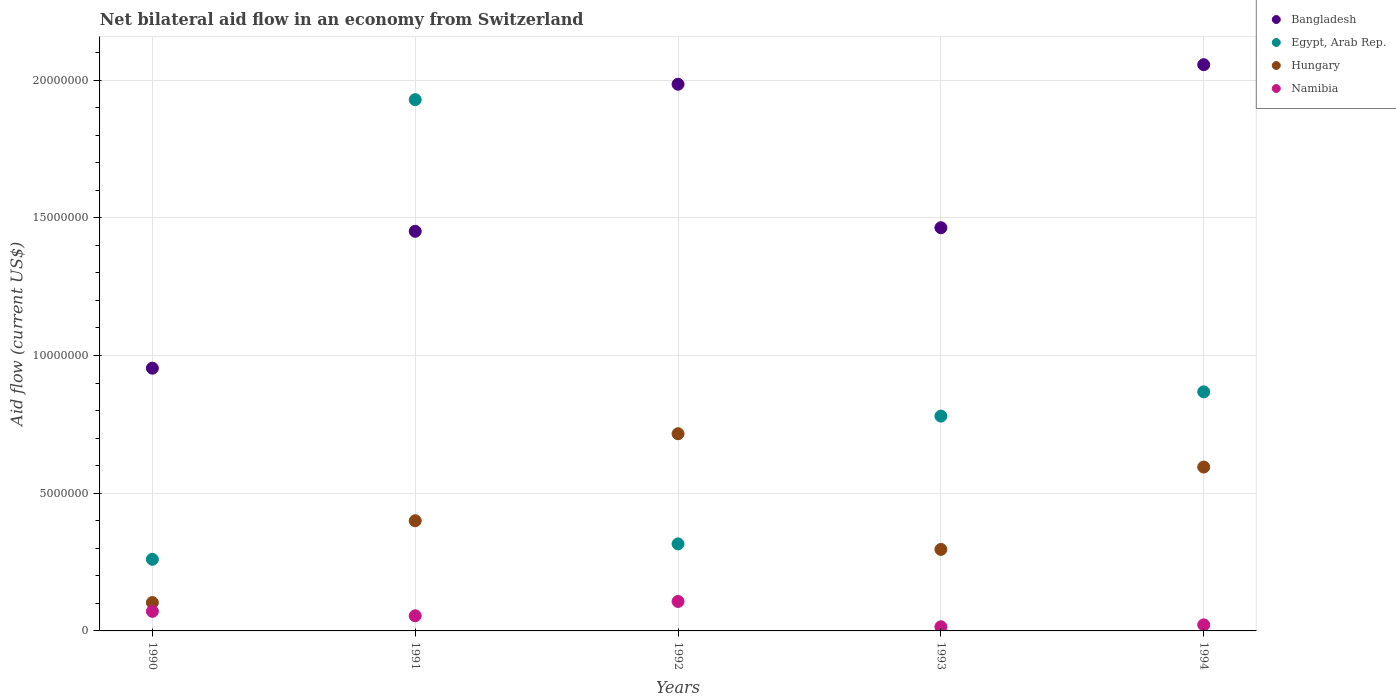How many different coloured dotlines are there?
Your answer should be compact. 4. Is the number of dotlines equal to the number of legend labels?
Provide a short and direct response. Yes. What is the net bilateral aid flow in Egypt, Arab Rep. in 1994?
Keep it short and to the point. 8.68e+06. Across all years, what is the maximum net bilateral aid flow in Bangladesh?
Provide a short and direct response. 2.06e+07. Across all years, what is the minimum net bilateral aid flow in Bangladesh?
Give a very brief answer. 9.54e+06. What is the total net bilateral aid flow in Hungary in the graph?
Give a very brief answer. 2.11e+07. What is the difference between the net bilateral aid flow in Hungary in 1990 and that in 1991?
Provide a short and direct response. -2.97e+06. What is the difference between the net bilateral aid flow in Namibia in 1994 and the net bilateral aid flow in Egypt, Arab Rep. in 1990?
Your answer should be compact. -2.38e+06. What is the average net bilateral aid flow in Bangladesh per year?
Give a very brief answer. 1.58e+07. In the year 1991, what is the difference between the net bilateral aid flow in Namibia and net bilateral aid flow in Bangladesh?
Offer a very short reply. -1.40e+07. What is the ratio of the net bilateral aid flow in Egypt, Arab Rep. in 1990 to that in 1991?
Make the answer very short. 0.13. Is the net bilateral aid flow in Hungary in 1992 less than that in 1994?
Offer a very short reply. No. Is the difference between the net bilateral aid flow in Namibia in 1992 and 1993 greater than the difference between the net bilateral aid flow in Bangladesh in 1992 and 1993?
Your response must be concise. No. What is the difference between the highest and the second highest net bilateral aid flow in Hungary?
Your response must be concise. 1.21e+06. What is the difference between the highest and the lowest net bilateral aid flow in Namibia?
Offer a terse response. 9.20e+05. Is the sum of the net bilateral aid flow in Egypt, Arab Rep. in 1991 and 1994 greater than the maximum net bilateral aid flow in Hungary across all years?
Your answer should be compact. Yes. Is the net bilateral aid flow in Bangladesh strictly greater than the net bilateral aid flow in Namibia over the years?
Make the answer very short. Yes. Is the net bilateral aid flow in Bangladesh strictly less than the net bilateral aid flow in Hungary over the years?
Offer a terse response. No. How many dotlines are there?
Offer a terse response. 4. Are the values on the major ticks of Y-axis written in scientific E-notation?
Provide a succinct answer. No. Does the graph contain any zero values?
Provide a succinct answer. No. How many legend labels are there?
Your response must be concise. 4. What is the title of the graph?
Keep it short and to the point. Net bilateral aid flow in an economy from Switzerland. What is the label or title of the Y-axis?
Keep it short and to the point. Aid flow (current US$). What is the Aid flow (current US$) in Bangladesh in 1990?
Your response must be concise. 9.54e+06. What is the Aid flow (current US$) in Egypt, Arab Rep. in 1990?
Make the answer very short. 2.60e+06. What is the Aid flow (current US$) in Hungary in 1990?
Offer a terse response. 1.03e+06. What is the Aid flow (current US$) of Namibia in 1990?
Your answer should be very brief. 7.10e+05. What is the Aid flow (current US$) of Bangladesh in 1991?
Provide a succinct answer. 1.45e+07. What is the Aid flow (current US$) in Egypt, Arab Rep. in 1991?
Offer a terse response. 1.93e+07. What is the Aid flow (current US$) of Hungary in 1991?
Provide a succinct answer. 4.00e+06. What is the Aid flow (current US$) in Bangladesh in 1992?
Give a very brief answer. 1.98e+07. What is the Aid flow (current US$) of Egypt, Arab Rep. in 1992?
Your answer should be very brief. 3.16e+06. What is the Aid flow (current US$) of Hungary in 1992?
Give a very brief answer. 7.16e+06. What is the Aid flow (current US$) of Namibia in 1992?
Ensure brevity in your answer.  1.07e+06. What is the Aid flow (current US$) of Bangladesh in 1993?
Keep it short and to the point. 1.46e+07. What is the Aid flow (current US$) of Egypt, Arab Rep. in 1993?
Your answer should be compact. 7.80e+06. What is the Aid flow (current US$) in Hungary in 1993?
Give a very brief answer. 2.96e+06. What is the Aid flow (current US$) of Bangladesh in 1994?
Provide a short and direct response. 2.06e+07. What is the Aid flow (current US$) of Egypt, Arab Rep. in 1994?
Your answer should be compact. 8.68e+06. What is the Aid flow (current US$) of Hungary in 1994?
Offer a terse response. 5.95e+06. What is the Aid flow (current US$) of Namibia in 1994?
Offer a terse response. 2.20e+05. Across all years, what is the maximum Aid flow (current US$) of Bangladesh?
Your answer should be very brief. 2.06e+07. Across all years, what is the maximum Aid flow (current US$) in Egypt, Arab Rep.?
Your answer should be compact. 1.93e+07. Across all years, what is the maximum Aid flow (current US$) of Hungary?
Give a very brief answer. 7.16e+06. Across all years, what is the maximum Aid flow (current US$) of Namibia?
Provide a succinct answer. 1.07e+06. Across all years, what is the minimum Aid flow (current US$) of Bangladesh?
Ensure brevity in your answer.  9.54e+06. Across all years, what is the minimum Aid flow (current US$) of Egypt, Arab Rep.?
Your answer should be compact. 2.60e+06. Across all years, what is the minimum Aid flow (current US$) of Hungary?
Your answer should be very brief. 1.03e+06. Across all years, what is the minimum Aid flow (current US$) in Namibia?
Your answer should be compact. 1.50e+05. What is the total Aid flow (current US$) of Bangladesh in the graph?
Make the answer very short. 7.91e+07. What is the total Aid flow (current US$) of Egypt, Arab Rep. in the graph?
Provide a short and direct response. 4.15e+07. What is the total Aid flow (current US$) of Hungary in the graph?
Your answer should be compact. 2.11e+07. What is the total Aid flow (current US$) in Namibia in the graph?
Your answer should be very brief. 2.70e+06. What is the difference between the Aid flow (current US$) of Bangladesh in 1990 and that in 1991?
Your answer should be very brief. -4.97e+06. What is the difference between the Aid flow (current US$) in Egypt, Arab Rep. in 1990 and that in 1991?
Your answer should be very brief. -1.67e+07. What is the difference between the Aid flow (current US$) in Hungary in 1990 and that in 1991?
Provide a succinct answer. -2.97e+06. What is the difference between the Aid flow (current US$) in Bangladesh in 1990 and that in 1992?
Offer a terse response. -1.03e+07. What is the difference between the Aid flow (current US$) of Egypt, Arab Rep. in 1990 and that in 1992?
Offer a terse response. -5.60e+05. What is the difference between the Aid flow (current US$) in Hungary in 1990 and that in 1992?
Ensure brevity in your answer.  -6.13e+06. What is the difference between the Aid flow (current US$) in Namibia in 1990 and that in 1992?
Your response must be concise. -3.60e+05. What is the difference between the Aid flow (current US$) of Bangladesh in 1990 and that in 1993?
Keep it short and to the point. -5.10e+06. What is the difference between the Aid flow (current US$) of Egypt, Arab Rep. in 1990 and that in 1993?
Provide a succinct answer. -5.20e+06. What is the difference between the Aid flow (current US$) in Hungary in 1990 and that in 1993?
Make the answer very short. -1.93e+06. What is the difference between the Aid flow (current US$) in Namibia in 1990 and that in 1993?
Make the answer very short. 5.60e+05. What is the difference between the Aid flow (current US$) of Bangladesh in 1990 and that in 1994?
Provide a short and direct response. -1.10e+07. What is the difference between the Aid flow (current US$) of Egypt, Arab Rep. in 1990 and that in 1994?
Your answer should be very brief. -6.08e+06. What is the difference between the Aid flow (current US$) in Hungary in 1990 and that in 1994?
Offer a very short reply. -4.92e+06. What is the difference between the Aid flow (current US$) of Namibia in 1990 and that in 1994?
Your answer should be compact. 4.90e+05. What is the difference between the Aid flow (current US$) of Bangladesh in 1991 and that in 1992?
Provide a short and direct response. -5.34e+06. What is the difference between the Aid flow (current US$) in Egypt, Arab Rep. in 1991 and that in 1992?
Offer a very short reply. 1.61e+07. What is the difference between the Aid flow (current US$) in Hungary in 1991 and that in 1992?
Your response must be concise. -3.16e+06. What is the difference between the Aid flow (current US$) of Namibia in 1991 and that in 1992?
Provide a short and direct response. -5.20e+05. What is the difference between the Aid flow (current US$) in Bangladesh in 1991 and that in 1993?
Offer a terse response. -1.30e+05. What is the difference between the Aid flow (current US$) of Egypt, Arab Rep. in 1991 and that in 1993?
Keep it short and to the point. 1.15e+07. What is the difference between the Aid flow (current US$) of Hungary in 1991 and that in 1993?
Your answer should be very brief. 1.04e+06. What is the difference between the Aid flow (current US$) in Bangladesh in 1991 and that in 1994?
Ensure brevity in your answer.  -6.05e+06. What is the difference between the Aid flow (current US$) in Egypt, Arab Rep. in 1991 and that in 1994?
Offer a very short reply. 1.06e+07. What is the difference between the Aid flow (current US$) in Hungary in 1991 and that in 1994?
Offer a very short reply. -1.95e+06. What is the difference between the Aid flow (current US$) in Namibia in 1991 and that in 1994?
Keep it short and to the point. 3.30e+05. What is the difference between the Aid flow (current US$) in Bangladesh in 1992 and that in 1993?
Your answer should be compact. 5.21e+06. What is the difference between the Aid flow (current US$) in Egypt, Arab Rep. in 1992 and that in 1993?
Provide a short and direct response. -4.64e+06. What is the difference between the Aid flow (current US$) of Hungary in 1992 and that in 1993?
Provide a short and direct response. 4.20e+06. What is the difference between the Aid flow (current US$) of Namibia in 1992 and that in 1993?
Make the answer very short. 9.20e+05. What is the difference between the Aid flow (current US$) of Bangladesh in 1992 and that in 1994?
Provide a succinct answer. -7.10e+05. What is the difference between the Aid flow (current US$) in Egypt, Arab Rep. in 1992 and that in 1994?
Offer a very short reply. -5.52e+06. What is the difference between the Aid flow (current US$) in Hungary in 1992 and that in 1994?
Your answer should be very brief. 1.21e+06. What is the difference between the Aid flow (current US$) of Namibia in 1992 and that in 1994?
Ensure brevity in your answer.  8.50e+05. What is the difference between the Aid flow (current US$) in Bangladesh in 1993 and that in 1994?
Offer a very short reply. -5.92e+06. What is the difference between the Aid flow (current US$) of Egypt, Arab Rep. in 1993 and that in 1994?
Offer a very short reply. -8.80e+05. What is the difference between the Aid flow (current US$) of Hungary in 1993 and that in 1994?
Your answer should be compact. -2.99e+06. What is the difference between the Aid flow (current US$) of Bangladesh in 1990 and the Aid flow (current US$) of Egypt, Arab Rep. in 1991?
Your response must be concise. -9.75e+06. What is the difference between the Aid flow (current US$) in Bangladesh in 1990 and the Aid flow (current US$) in Hungary in 1991?
Provide a succinct answer. 5.54e+06. What is the difference between the Aid flow (current US$) of Bangladesh in 1990 and the Aid flow (current US$) of Namibia in 1991?
Keep it short and to the point. 8.99e+06. What is the difference between the Aid flow (current US$) of Egypt, Arab Rep. in 1990 and the Aid flow (current US$) of Hungary in 1991?
Keep it short and to the point. -1.40e+06. What is the difference between the Aid flow (current US$) in Egypt, Arab Rep. in 1990 and the Aid flow (current US$) in Namibia in 1991?
Make the answer very short. 2.05e+06. What is the difference between the Aid flow (current US$) of Bangladesh in 1990 and the Aid flow (current US$) of Egypt, Arab Rep. in 1992?
Provide a short and direct response. 6.38e+06. What is the difference between the Aid flow (current US$) of Bangladesh in 1990 and the Aid flow (current US$) of Hungary in 1992?
Make the answer very short. 2.38e+06. What is the difference between the Aid flow (current US$) of Bangladesh in 1990 and the Aid flow (current US$) of Namibia in 1992?
Your answer should be compact. 8.47e+06. What is the difference between the Aid flow (current US$) of Egypt, Arab Rep. in 1990 and the Aid flow (current US$) of Hungary in 1992?
Make the answer very short. -4.56e+06. What is the difference between the Aid flow (current US$) of Egypt, Arab Rep. in 1990 and the Aid flow (current US$) of Namibia in 1992?
Provide a succinct answer. 1.53e+06. What is the difference between the Aid flow (current US$) in Hungary in 1990 and the Aid flow (current US$) in Namibia in 1992?
Your response must be concise. -4.00e+04. What is the difference between the Aid flow (current US$) in Bangladesh in 1990 and the Aid flow (current US$) in Egypt, Arab Rep. in 1993?
Provide a short and direct response. 1.74e+06. What is the difference between the Aid flow (current US$) of Bangladesh in 1990 and the Aid flow (current US$) of Hungary in 1993?
Ensure brevity in your answer.  6.58e+06. What is the difference between the Aid flow (current US$) of Bangladesh in 1990 and the Aid flow (current US$) of Namibia in 1993?
Provide a short and direct response. 9.39e+06. What is the difference between the Aid flow (current US$) in Egypt, Arab Rep. in 1990 and the Aid flow (current US$) in Hungary in 1993?
Offer a terse response. -3.60e+05. What is the difference between the Aid flow (current US$) of Egypt, Arab Rep. in 1990 and the Aid flow (current US$) of Namibia in 1993?
Provide a short and direct response. 2.45e+06. What is the difference between the Aid flow (current US$) of Hungary in 1990 and the Aid flow (current US$) of Namibia in 1993?
Offer a terse response. 8.80e+05. What is the difference between the Aid flow (current US$) of Bangladesh in 1990 and the Aid flow (current US$) of Egypt, Arab Rep. in 1994?
Give a very brief answer. 8.60e+05. What is the difference between the Aid flow (current US$) of Bangladesh in 1990 and the Aid flow (current US$) of Hungary in 1994?
Ensure brevity in your answer.  3.59e+06. What is the difference between the Aid flow (current US$) in Bangladesh in 1990 and the Aid flow (current US$) in Namibia in 1994?
Your response must be concise. 9.32e+06. What is the difference between the Aid flow (current US$) of Egypt, Arab Rep. in 1990 and the Aid flow (current US$) of Hungary in 1994?
Your answer should be compact. -3.35e+06. What is the difference between the Aid flow (current US$) of Egypt, Arab Rep. in 1990 and the Aid flow (current US$) of Namibia in 1994?
Offer a very short reply. 2.38e+06. What is the difference between the Aid flow (current US$) of Hungary in 1990 and the Aid flow (current US$) of Namibia in 1994?
Provide a succinct answer. 8.10e+05. What is the difference between the Aid flow (current US$) in Bangladesh in 1991 and the Aid flow (current US$) in Egypt, Arab Rep. in 1992?
Your response must be concise. 1.14e+07. What is the difference between the Aid flow (current US$) in Bangladesh in 1991 and the Aid flow (current US$) in Hungary in 1992?
Your answer should be compact. 7.35e+06. What is the difference between the Aid flow (current US$) of Bangladesh in 1991 and the Aid flow (current US$) of Namibia in 1992?
Make the answer very short. 1.34e+07. What is the difference between the Aid flow (current US$) in Egypt, Arab Rep. in 1991 and the Aid flow (current US$) in Hungary in 1992?
Keep it short and to the point. 1.21e+07. What is the difference between the Aid flow (current US$) in Egypt, Arab Rep. in 1991 and the Aid flow (current US$) in Namibia in 1992?
Provide a short and direct response. 1.82e+07. What is the difference between the Aid flow (current US$) in Hungary in 1991 and the Aid flow (current US$) in Namibia in 1992?
Provide a succinct answer. 2.93e+06. What is the difference between the Aid flow (current US$) in Bangladesh in 1991 and the Aid flow (current US$) in Egypt, Arab Rep. in 1993?
Give a very brief answer. 6.71e+06. What is the difference between the Aid flow (current US$) of Bangladesh in 1991 and the Aid flow (current US$) of Hungary in 1993?
Make the answer very short. 1.16e+07. What is the difference between the Aid flow (current US$) of Bangladesh in 1991 and the Aid flow (current US$) of Namibia in 1993?
Your answer should be very brief. 1.44e+07. What is the difference between the Aid flow (current US$) of Egypt, Arab Rep. in 1991 and the Aid flow (current US$) of Hungary in 1993?
Ensure brevity in your answer.  1.63e+07. What is the difference between the Aid flow (current US$) in Egypt, Arab Rep. in 1991 and the Aid flow (current US$) in Namibia in 1993?
Offer a terse response. 1.91e+07. What is the difference between the Aid flow (current US$) in Hungary in 1991 and the Aid flow (current US$) in Namibia in 1993?
Offer a terse response. 3.85e+06. What is the difference between the Aid flow (current US$) in Bangladesh in 1991 and the Aid flow (current US$) in Egypt, Arab Rep. in 1994?
Your response must be concise. 5.83e+06. What is the difference between the Aid flow (current US$) of Bangladesh in 1991 and the Aid flow (current US$) of Hungary in 1994?
Give a very brief answer. 8.56e+06. What is the difference between the Aid flow (current US$) in Bangladesh in 1991 and the Aid flow (current US$) in Namibia in 1994?
Provide a short and direct response. 1.43e+07. What is the difference between the Aid flow (current US$) in Egypt, Arab Rep. in 1991 and the Aid flow (current US$) in Hungary in 1994?
Give a very brief answer. 1.33e+07. What is the difference between the Aid flow (current US$) in Egypt, Arab Rep. in 1991 and the Aid flow (current US$) in Namibia in 1994?
Keep it short and to the point. 1.91e+07. What is the difference between the Aid flow (current US$) in Hungary in 1991 and the Aid flow (current US$) in Namibia in 1994?
Provide a succinct answer. 3.78e+06. What is the difference between the Aid flow (current US$) of Bangladesh in 1992 and the Aid flow (current US$) of Egypt, Arab Rep. in 1993?
Offer a very short reply. 1.20e+07. What is the difference between the Aid flow (current US$) of Bangladesh in 1992 and the Aid flow (current US$) of Hungary in 1993?
Your answer should be compact. 1.69e+07. What is the difference between the Aid flow (current US$) of Bangladesh in 1992 and the Aid flow (current US$) of Namibia in 1993?
Ensure brevity in your answer.  1.97e+07. What is the difference between the Aid flow (current US$) of Egypt, Arab Rep. in 1992 and the Aid flow (current US$) of Hungary in 1993?
Your answer should be compact. 2.00e+05. What is the difference between the Aid flow (current US$) in Egypt, Arab Rep. in 1992 and the Aid flow (current US$) in Namibia in 1993?
Your answer should be compact. 3.01e+06. What is the difference between the Aid flow (current US$) in Hungary in 1992 and the Aid flow (current US$) in Namibia in 1993?
Your response must be concise. 7.01e+06. What is the difference between the Aid flow (current US$) of Bangladesh in 1992 and the Aid flow (current US$) of Egypt, Arab Rep. in 1994?
Your answer should be compact. 1.12e+07. What is the difference between the Aid flow (current US$) of Bangladesh in 1992 and the Aid flow (current US$) of Hungary in 1994?
Provide a succinct answer. 1.39e+07. What is the difference between the Aid flow (current US$) of Bangladesh in 1992 and the Aid flow (current US$) of Namibia in 1994?
Provide a short and direct response. 1.96e+07. What is the difference between the Aid flow (current US$) in Egypt, Arab Rep. in 1992 and the Aid flow (current US$) in Hungary in 1994?
Keep it short and to the point. -2.79e+06. What is the difference between the Aid flow (current US$) of Egypt, Arab Rep. in 1992 and the Aid flow (current US$) of Namibia in 1994?
Keep it short and to the point. 2.94e+06. What is the difference between the Aid flow (current US$) of Hungary in 1992 and the Aid flow (current US$) of Namibia in 1994?
Provide a short and direct response. 6.94e+06. What is the difference between the Aid flow (current US$) in Bangladesh in 1993 and the Aid flow (current US$) in Egypt, Arab Rep. in 1994?
Your response must be concise. 5.96e+06. What is the difference between the Aid flow (current US$) of Bangladesh in 1993 and the Aid flow (current US$) of Hungary in 1994?
Your answer should be compact. 8.69e+06. What is the difference between the Aid flow (current US$) of Bangladesh in 1993 and the Aid flow (current US$) of Namibia in 1994?
Your answer should be very brief. 1.44e+07. What is the difference between the Aid flow (current US$) of Egypt, Arab Rep. in 1993 and the Aid flow (current US$) of Hungary in 1994?
Your answer should be compact. 1.85e+06. What is the difference between the Aid flow (current US$) in Egypt, Arab Rep. in 1993 and the Aid flow (current US$) in Namibia in 1994?
Provide a succinct answer. 7.58e+06. What is the difference between the Aid flow (current US$) of Hungary in 1993 and the Aid flow (current US$) of Namibia in 1994?
Offer a very short reply. 2.74e+06. What is the average Aid flow (current US$) in Bangladesh per year?
Your answer should be very brief. 1.58e+07. What is the average Aid flow (current US$) of Egypt, Arab Rep. per year?
Provide a short and direct response. 8.31e+06. What is the average Aid flow (current US$) of Hungary per year?
Offer a terse response. 4.22e+06. What is the average Aid flow (current US$) of Namibia per year?
Provide a short and direct response. 5.40e+05. In the year 1990, what is the difference between the Aid flow (current US$) of Bangladesh and Aid flow (current US$) of Egypt, Arab Rep.?
Provide a succinct answer. 6.94e+06. In the year 1990, what is the difference between the Aid flow (current US$) in Bangladesh and Aid flow (current US$) in Hungary?
Offer a very short reply. 8.51e+06. In the year 1990, what is the difference between the Aid flow (current US$) in Bangladesh and Aid flow (current US$) in Namibia?
Provide a succinct answer. 8.83e+06. In the year 1990, what is the difference between the Aid flow (current US$) in Egypt, Arab Rep. and Aid flow (current US$) in Hungary?
Ensure brevity in your answer.  1.57e+06. In the year 1990, what is the difference between the Aid flow (current US$) of Egypt, Arab Rep. and Aid flow (current US$) of Namibia?
Provide a short and direct response. 1.89e+06. In the year 1991, what is the difference between the Aid flow (current US$) of Bangladesh and Aid flow (current US$) of Egypt, Arab Rep.?
Make the answer very short. -4.78e+06. In the year 1991, what is the difference between the Aid flow (current US$) of Bangladesh and Aid flow (current US$) of Hungary?
Provide a succinct answer. 1.05e+07. In the year 1991, what is the difference between the Aid flow (current US$) of Bangladesh and Aid flow (current US$) of Namibia?
Keep it short and to the point. 1.40e+07. In the year 1991, what is the difference between the Aid flow (current US$) of Egypt, Arab Rep. and Aid flow (current US$) of Hungary?
Ensure brevity in your answer.  1.53e+07. In the year 1991, what is the difference between the Aid flow (current US$) of Egypt, Arab Rep. and Aid flow (current US$) of Namibia?
Make the answer very short. 1.87e+07. In the year 1991, what is the difference between the Aid flow (current US$) of Hungary and Aid flow (current US$) of Namibia?
Your answer should be very brief. 3.45e+06. In the year 1992, what is the difference between the Aid flow (current US$) of Bangladesh and Aid flow (current US$) of Egypt, Arab Rep.?
Your response must be concise. 1.67e+07. In the year 1992, what is the difference between the Aid flow (current US$) of Bangladesh and Aid flow (current US$) of Hungary?
Your answer should be very brief. 1.27e+07. In the year 1992, what is the difference between the Aid flow (current US$) of Bangladesh and Aid flow (current US$) of Namibia?
Your answer should be compact. 1.88e+07. In the year 1992, what is the difference between the Aid flow (current US$) in Egypt, Arab Rep. and Aid flow (current US$) in Hungary?
Offer a terse response. -4.00e+06. In the year 1992, what is the difference between the Aid flow (current US$) of Egypt, Arab Rep. and Aid flow (current US$) of Namibia?
Your response must be concise. 2.09e+06. In the year 1992, what is the difference between the Aid flow (current US$) of Hungary and Aid flow (current US$) of Namibia?
Keep it short and to the point. 6.09e+06. In the year 1993, what is the difference between the Aid flow (current US$) of Bangladesh and Aid flow (current US$) of Egypt, Arab Rep.?
Ensure brevity in your answer.  6.84e+06. In the year 1993, what is the difference between the Aid flow (current US$) in Bangladesh and Aid flow (current US$) in Hungary?
Provide a short and direct response. 1.17e+07. In the year 1993, what is the difference between the Aid flow (current US$) of Bangladesh and Aid flow (current US$) of Namibia?
Your response must be concise. 1.45e+07. In the year 1993, what is the difference between the Aid flow (current US$) of Egypt, Arab Rep. and Aid flow (current US$) of Hungary?
Your answer should be very brief. 4.84e+06. In the year 1993, what is the difference between the Aid flow (current US$) of Egypt, Arab Rep. and Aid flow (current US$) of Namibia?
Provide a succinct answer. 7.65e+06. In the year 1993, what is the difference between the Aid flow (current US$) of Hungary and Aid flow (current US$) of Namibia?
Make the answer very short. 2.81e+06. In the year 1994, what is the difference between the Aid flow (current US$) in Bangladesh and Aid flow (current US$) in Egypt, Arab Rep.?
Your answer should be very brief. 1.19e+07. In the year 1994, what is the difference between the Aid flow (current US$) in Bangladesh and Aid flow (current US$) in Hungary?
Your response must be concise. 1.46e+07. In the year 1994, what is the difference between the Aid flow (current US$) in Bangladesh and Aid flow (current US$) in Namibia?
Your answer should be very brief. 2.03e+07. In the year 1994, what is the difference between the Aid flow (current US$) in Egypt, Arab Rep. and Aid flow (current US$) in Hungary?
Offer a very short reply. 2.73e+06. In the year 1994, what is the difference between the Aid flow (current US$) of Egypt, Arab Rep. and Aid flow (current US$) of Namibia?
Your response must be concise. 8.46e+06. In the year 1994, what is the difference between the Aid flow (current US$) in Hungary and Aid flow (current US$) in Namibia?
Offer a terse response. 5.73e+06. What is the ratio of the Aid flow (current US$) of Bangladesh in 1990 to that in 1991?
Provide a succinct answer. 0.66. What is the ratio of the Aid flow (current US$) of Egypt, Arab Rep. in 1990 to that in 1991?
Provide a succinct answer. 0.13. What is the ratio of the Aid flow (current US$) in Hungary in 1990 to that in 1991?
Your response must be concise. 0.26. What is the ratio of the Aid flow (current US$) of Namibia in 1990 to that in 1991?
Offer a terse response. 1.29. What is the ratio of the Aid flow (current US$) in Bangladesh in 1990 to that in 1992?
Your answer should be very brief. 0.48. What is the ratio of the Aid flow (current US$) of Egypt, Arab Rep. in 1990 to that in 1992?
Make the answer very short. 0.82. What is the ratio of the Aid flow (current US$) in Hungary in 1990 to that in 1992?
Offer a very short reply. 0.14. What is the ratio of the Aid flow (current US$) of Namibia in 1990 to that in 1992?
Provide a short and direct response. 0.66. What is the ratio of the Aid flow (current US$) in Bangladesh in 1990 to that in 1993?
Your response must be concise. 0.65. What is the ratio of the Aid flow (current US$) in Egypt, Arab Rep. in 1990 to that in 1993?
Ensure brevity in your answer.  0.33. What is the ratio of the Aid flow (current US$) of Hungary in 1990 to that in 1993?
Your response must be concise. 0.35. What is the ratio of the Aid flow (current US$) in Namibia in 1990 to that in 1993?
Your answer should be very brief. 4.73. What is the ratio of the Aid flow (current US$) in Bangladesh in 1990 to that in 1994?
Your response must be concise. 0.46. What is the ratio of the Aid flow (current US$) in Egypt, Arab Rep. in 1990 to that in 1994?
Your answer should be compact. 0.3. What is the ratio of the Aid flow (current US$) in Hungary in 1990 to that in 1994?
Provide a short and direct response. 0.17. What is the ratio of the Aid flow (current US$) of Namibia in 1990 to that in 1994?
Your answer should be very brief. 3.23. What is the ratio of the Aid flow (current US$) in Bangladesh in 1991 to that in 1992?
Make the answer very short. 0.73. What is the ratio of the Aid flow (current US$) in Egypt, Arab Rep. in 1991 to that in 1992?
Your answer should be compact. 6.1. What is the ratio of the Aid flow (current US$) in Hungary in 1991 to that in 1992?
Provide a succinct answer. 0.56. What is the ratio of the Aid flow (current US$) of Namibia in 1991 to that in 1992?
Your response must be concise. 0.51. What is the ratio of the Aid flow (current US$) of Bangladesh in 1991 to that in 1993?
Provide a short and direct response. 0.99. What is the ratio of the Aid flow (current US$) in Egypt, Arab Rep. in 1991 to that in 1993?
Provide a succinct answer. 2.47. What is the ratio of the Aid flow (current US$) in Hungary in 1991 to that in 1993?
Provide a succinct answer. 1.35. What is the ratio of the Aid flow (current US$) in Namibia in 1991 to that in 1993?
Your answer should be very brief. 3.67. What is the ratio of the Aid flow (current US$) in Bangladesh in 1991 to that in 1994?
Offer a terse response. 0.71. What is the ratio of the Aid flow (current US$) of Egypt, Arab Rep. in 1991 to that in 1994?
Provide a succinct answer. 2.22. What is the ratio of the Aid flow (current US$) in Hungary in 1991 to that in 1994?
Your answer should be compact. 0.67. What is the ratio of the Aid flow (current US$) of Bangladesh in 1992 to that in 1993?
Offer a terse response. 1.36. What is the ratio of the Aid flow (current US$) in Egypt, Arab Rep. in 1992 to that in 1993?
Your response must be concise. 0.41. What is the ratio of the Aid flow (current US$) in Hungary in 1992 to that in 1993?
Provide a short and direct response. 2.42. What is the ratio of the Aid flow (current US$) of Namibia in 1992 to that in 1993?
Keep it short and to the point. 7.13. What is the ratio of the Aid flow (current US$) in Bangladesh in 1992 to that in 1994?
Make the answer very short. 0.97. What is the ratio of the Aid flow (current US$) in Egypt, Arab Rep. in 1992 to that in 1994?
Offer a terse response. 0.36. What is the ratio of the Aid flow (current US$) of Hungary in 1992 to that in 1994?
Keep it short and to the point. 1.2. What is the ratio of the Aid flow (current US$) in Namibia in 1992 to that in 1994?
Your response must be concise. 4.86. What is the ratio of the Aid flow (current US$) in Bangladesh in 1993 to that in 1994?
Keep it short and to the point. 0.71. What is the ratio of the Aid flow (current US$) in Egypt, Arab Rep. in 1993 to that in 1994?
Provide a short and direct response. 0.9. What is the ratio of the Aid flow (current US$) in Hungary in 1993 to that in 1994?
Offer a very short reply. 0.5. What is the ratio of the Aid flow (current US$) in Namibia in 1993 to that in 1994?
Give a very brief answer. 0.68. What is the difference between the highest and the second highest Aid flow (current US$) in Bangladesh?
Your answer should be compact. 7.10e+05. What is the difference between the highest and the second highest Aid flow (current US$) of Egypt, Arab Rep.?
Ensure brevity in your answer.  1.06e+07. What is the difference between the highest and the second highest Aid flow (current US$) in Hungary?
Provide a short and direct response. 1.21e+06. What is the difference between the highest and the second highest Aid flow (current US$) of Namibia?
Keep it short and to the point. 3.60e+05. What is the difference between the highest and the lowest Aid flow (current US$) of Bangladesh?
Offer a very short reply. 1.10e+07. What is the difference between the highest and the lowest Aid flow (current US$) of Egypt, Arab Rep.?
Offer a terse response. 1.67e+07. What is the difference between the highest and the lowest Aid flow (current US$) in Hungary?
Ensure brevity in your answer.  6.13e+06. What is the difference between the highest and the lowest Aid flow (current US$) of Namibia?
Your answer should be very brief. 9.20e+05. 